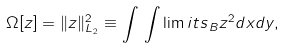<formula> <loc_0><loc_0><loc_500><loc_500>\Omega [ z ] = \| z \| ^ { 2 } _ { L _ { 2 } } \equiv \int \, \int \lim i t s _ { \, B } z ^ { 2 } d x d y ,</formula> 